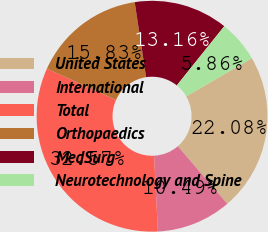Convert chart. <chart><loc_0><loc_0><loc_500><loc_500><pie_chart><fcel>United States<fcel>International<fcel>Total<fcel>Orthopaedics<fcel>MedSurg<fcel>Neurotechnology and Spine<nl><fcel>22.08%<fcel>10.49%<fcel>32.57%<fcel>15.83%<fcel>13.16%<fcel>5.86%<nl></chart> 